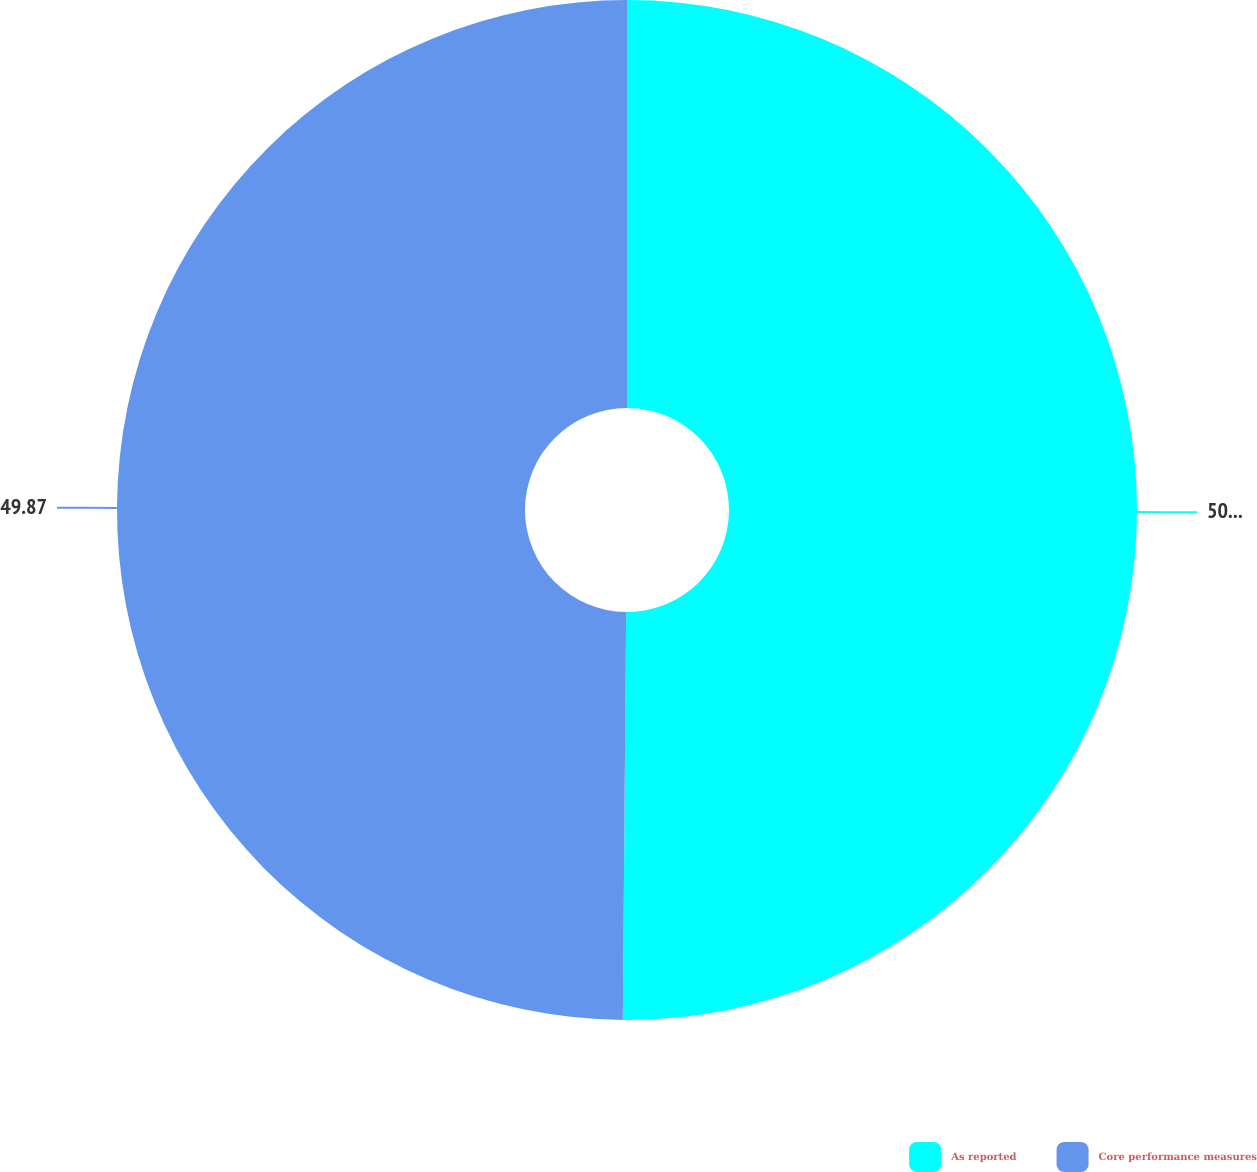Convert chart to OTSL. <chart><loc_0><loc_0><loc_500><loc_500><pie_chart><fcel>As reported<fcel>Core performance measures<nl><fcel>50.13%<fcel>49.87%<nl></chart> 